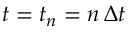Convert formula to latex. <formula><loc_0><loc_0><loc_500><loc_500>t = t _ { n } = n \, \Delta t</formula> 